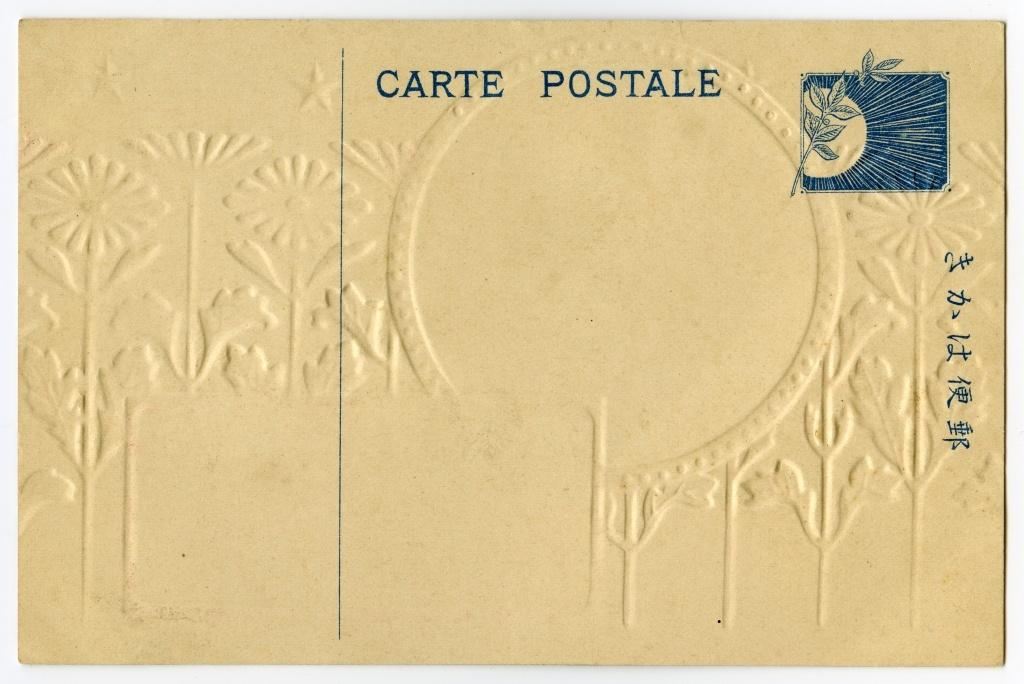<image>
Create a compact narrative representing the image presented. The white Carte Postale postcard has some flower etching in the background. 